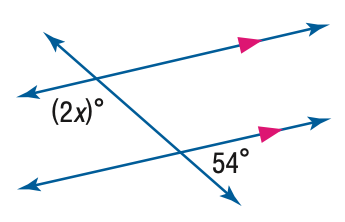Question: Find the value of the variable x in the figure.
Choices:
A. 27
B. 54
C. 63
D. 126
Answer with the letter. Answer: C 